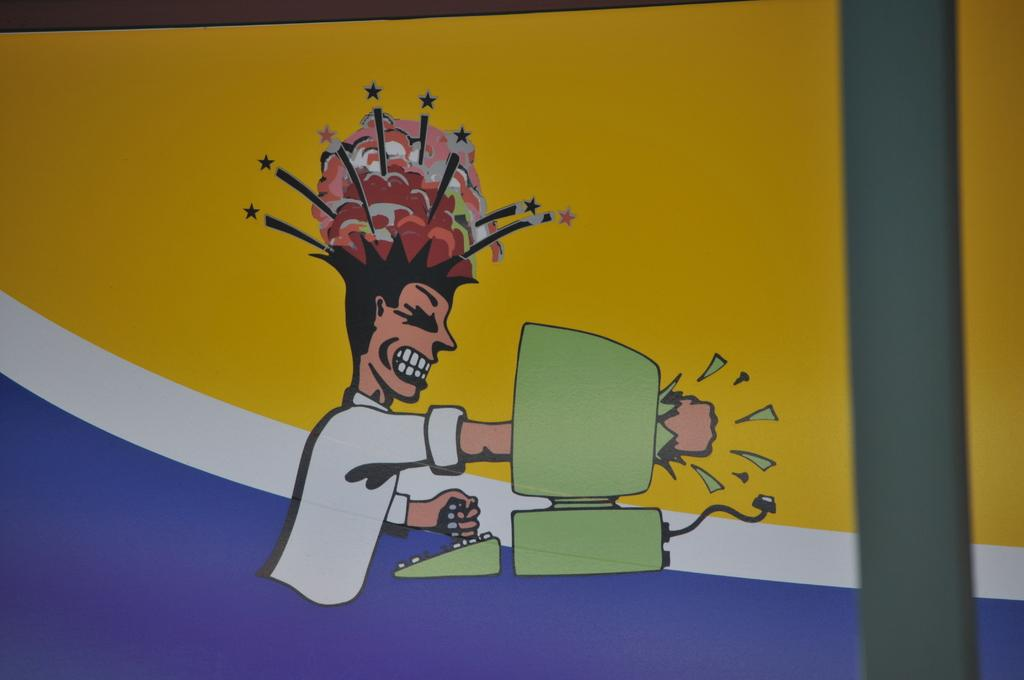What is depicted in the painting in the image? There is a painting of a person in the image. What electronic device is present in the image? There is a monitor in the image. What is used for typing or inputting commands in the image? There is a keyboard in the image. What connects the devices in the image? There is a cable in the image. Can you hear the person in the painting crying in the image? There is no sound or indication of crying in the image; it is a still painting of a person. 